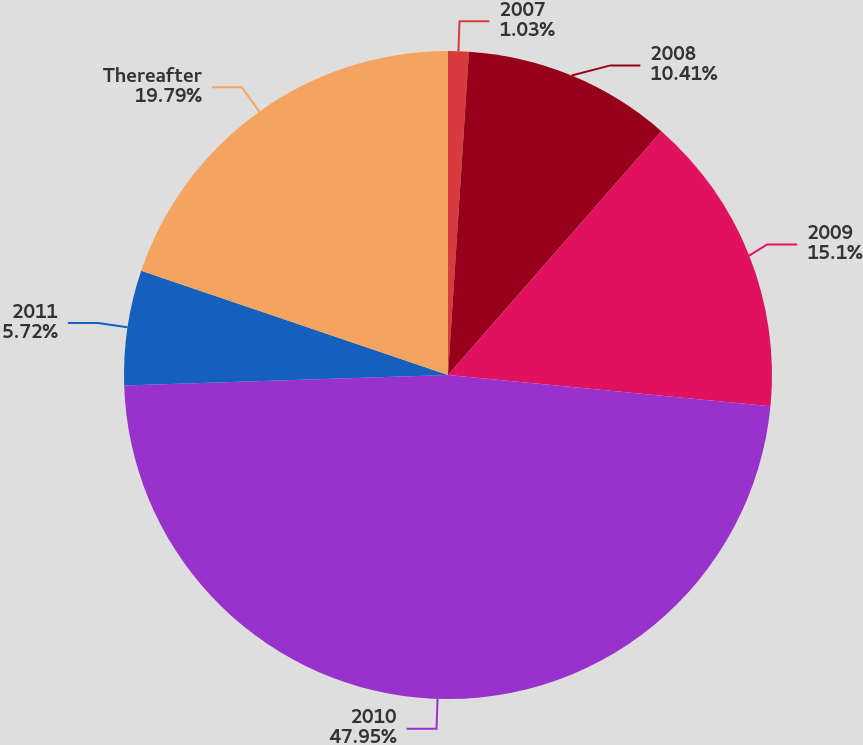Convert chart. <chart><loc_0><loc_0><loc_500><loc_500><pie_chart><fcel>2007<fcel>2008<fcel>2009<fcel>2010<fcel>2011<fcel>Thereafter<nl><fcel>1.03%<fcel>10.41%<fcel>15.1%<fcel>47.95%<fcel>5.72%<fcel>19.79%<nl></chart> 